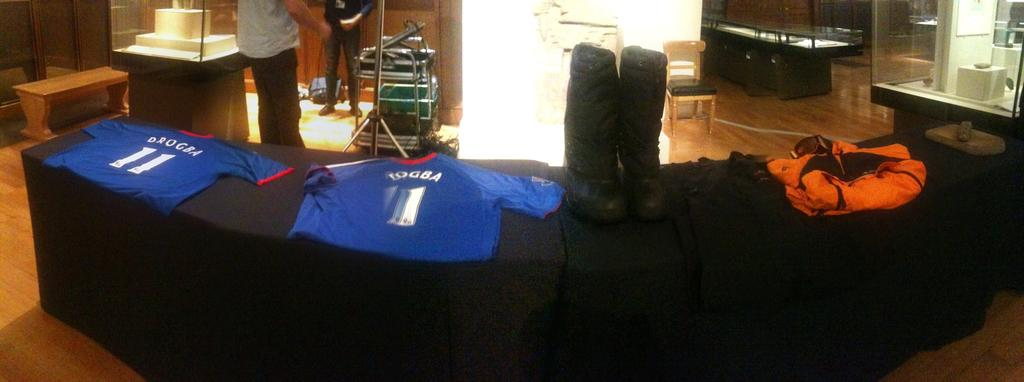<image>
Give a short and clear explanation of the subsequent image. Two blue shirts on a shelf with one saying DROGBA and the number 11. 